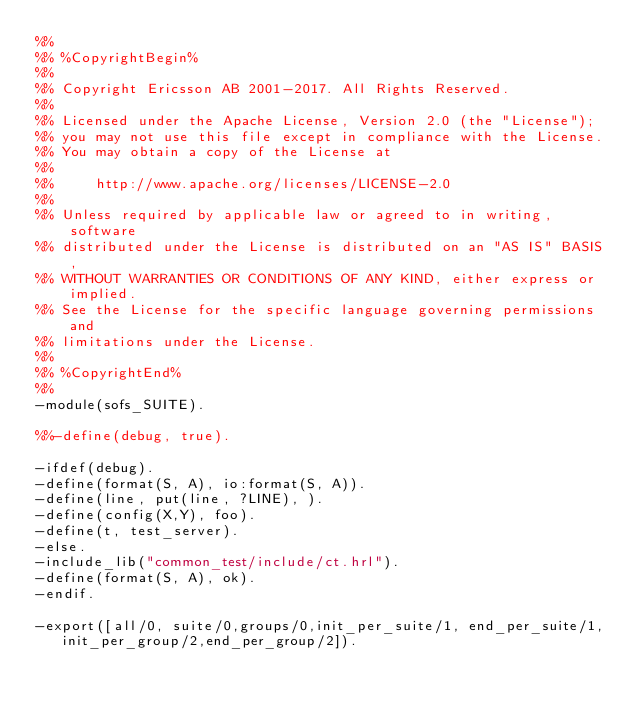Convert code to text. <code><loc_0><loc_0><loc_500><loc_500><_Erlang_>%%
%% %CopyrightBegin%
%%
%% Copyright Ericsson AB 2001-2017. All Rights Reserved.
%%
%% Licensed under the Apache License, Version 2.0 (the "License");
%% you may not use this file except in compliance with the License.
%% You may obtain a copy of the License at
%%
%%     http://www.apache.org/licenses/LICENSE-2.0
%%
%% Unless required by applicable law or agreed to in writing, software
%% distributed under the License is distributed on an "AS IS" BASIS,
%% WITHOUT WARRANTIES OR CONDITIONS OF ANY KIND, either express or implied.
%% See the License for the specific language governing permissions and
%% limitations under the License.
%%
%% %CopyrightEnd%
%%
-module(sofs_SUITE).

%%-define(debug, true).

-ifdef(debug).
-define(format(S, A), io:format(S, A)).
-define(line, put(line, ?LINE), ).
-define(config(X,Y), foo).
-define(t, test_server).
-else.
-include_lib("common_test/include/ct.hrl").
-define(format(S, A), ok).
-endif.

-export([all/0, suite/0,groups/0,init_per_suite/1, end_per_suite/1, 
	 init_per_group/2,end_per_group/2]).
</code> 